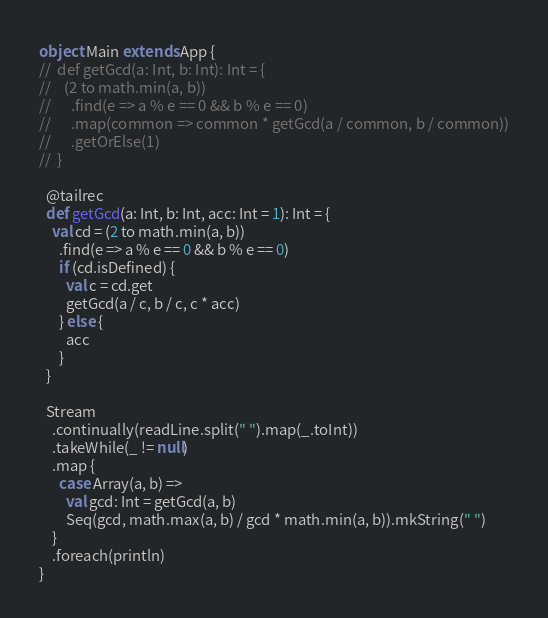<code> <loc_0><loc_0><loc_500><loc_500><_Scala_>object Main extends App {
//  def getGcd(a: Int, b: Int): Int = {
//    (2 to math.min(a, b))
//      .find(e => a % e == 0 && b % e == 0)
//      .map(common => common * getGcd(a / common, b / common))
//      .getOrElse(1)
//  }

  @tailrec
  def getGcd(a: Int, b: Int, acc: Int = 1): Int = {
    val cd = (2 to math.min(a, b))
      .find(e => a % e == 0 && b % e == 0)
      if (cd.isDefined) {
        val c = cd.get
        getGcd(a / c, b / c, c * acc)
      } else {
        acc
      }
  }

  Stream
    .continually(readLine.split(" ").map(_.toInt))
    .takeWhile(_ != null)
    .map {
      case Array(a, b) =>
        val gcd: Int = getGcd(a, b)
        Seq(gcd, math.max(a, b) / gcd * math.min(a, b)).mkString(" ")
    }
    .foreach(println)
}

</code> 